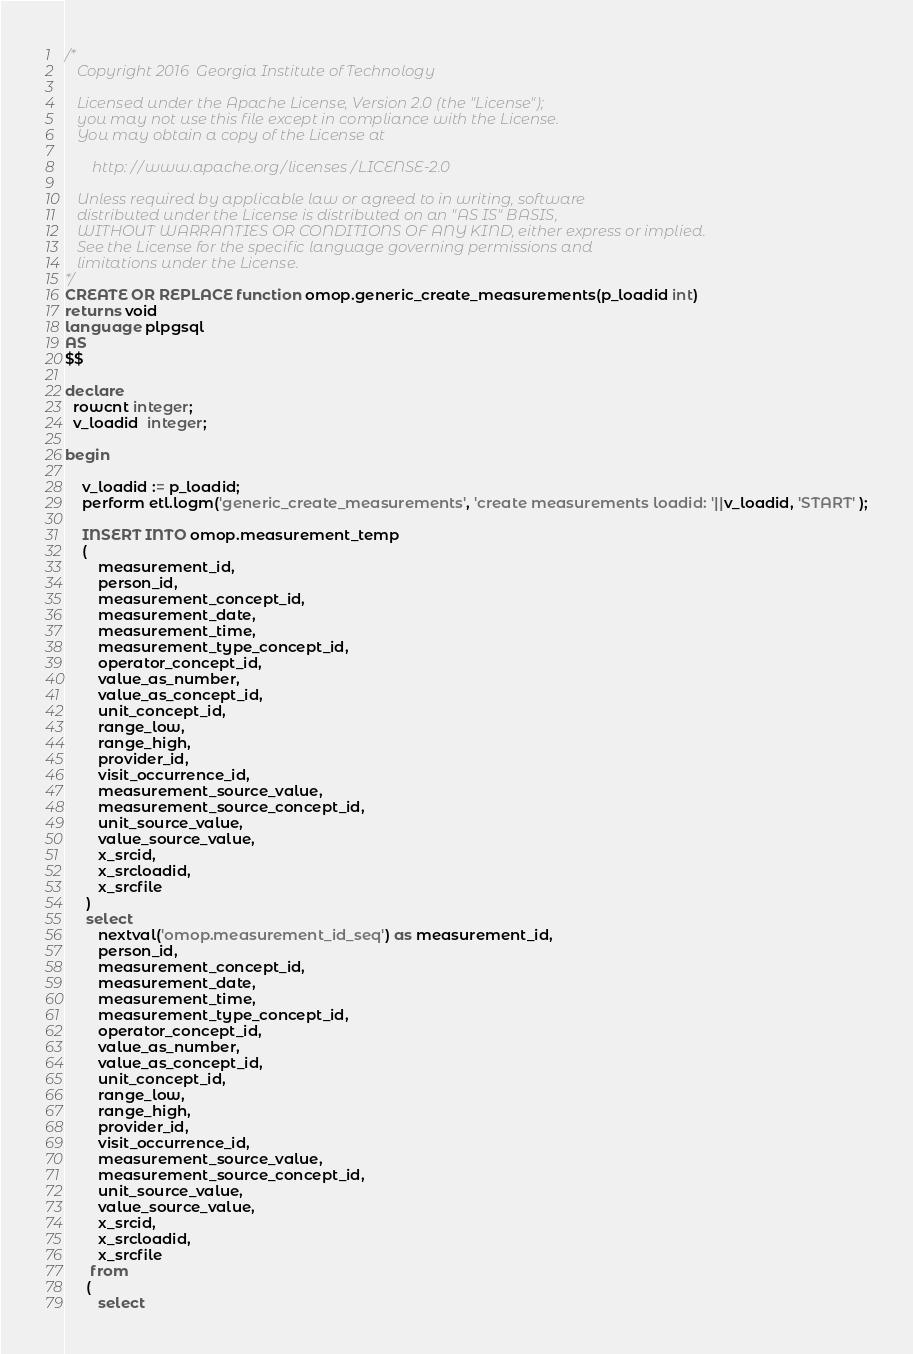<code> <loc_0><loc_0><loc_500><loc_500><_SQL_>/*
   Copyright 2016  Georgia Institute of Technology

   Licensed under the Apache License, Version 2.0 (the "License");
   you may not use this file except in compliance with the License.
   You may obtain a copy of the License at

       http://www.apache.org/licenses/LICENSE-2.0

   Unless required by applicable law or agreed to in writing, software
   distributed under the License is distributed on an "AS IS" BASIS,
   WITHOUT WARRANTIES OR CONDITIONS OF ANY KIND, either express or implied.
   See the License for the specific language governing permissions and
   limitations under the License. 
*/
CREATE OR REPLACE function omop.generic_create_measurements(p_loadid int)
returns void
language plpgsql
AS 
$$

declare
  rowcnt integer;
  v_loadid  integer;

begin

    v_loadid := p_loadid; 
    perform etl.logm('generic_create_measurements', 'create measurements loadid: '||v_loadid, 'START' );
    
    INSERT INTO omop.measurement_temp
    (
        measurement_id,
        person_id,
        measurement_concept_id,
        measurement_date,
        measurement_time,
        measurement_type_concept_id,
        operator_concept_id,
        value_as_number,
        value_as_concept_id,
        unit_concept_id,
        range_low,
        range_high,
        provider_id,
        visit_occurrence_id,
        measurement_source_value,
        measurement_source_concept_id,
        unit_source_value,
        value_source_value,
        x_srcid,
        x_srcloadid,
        x_srcfile
     )
     select
        nextval('omop.measurement_id_seq') as measurement_id,
        person_id,
        measurement_concept_id,
        measurement_date,
        measurement_time,
        measurement_type_concept_id,
        operator_concept_id,
        value_as_number,
        value_as_concept_id,
        unit_concept_id,
        range_low,
        range_high,
        provider_id,
        visit_occurrence_id,
        measurement_source_value,
        measurement_source_concept_id,
        unit_source_value,
        value_source_value,
        x_srcid,
        x_srcloadid,
        x_srcfile
      from
     (
        select</code> 